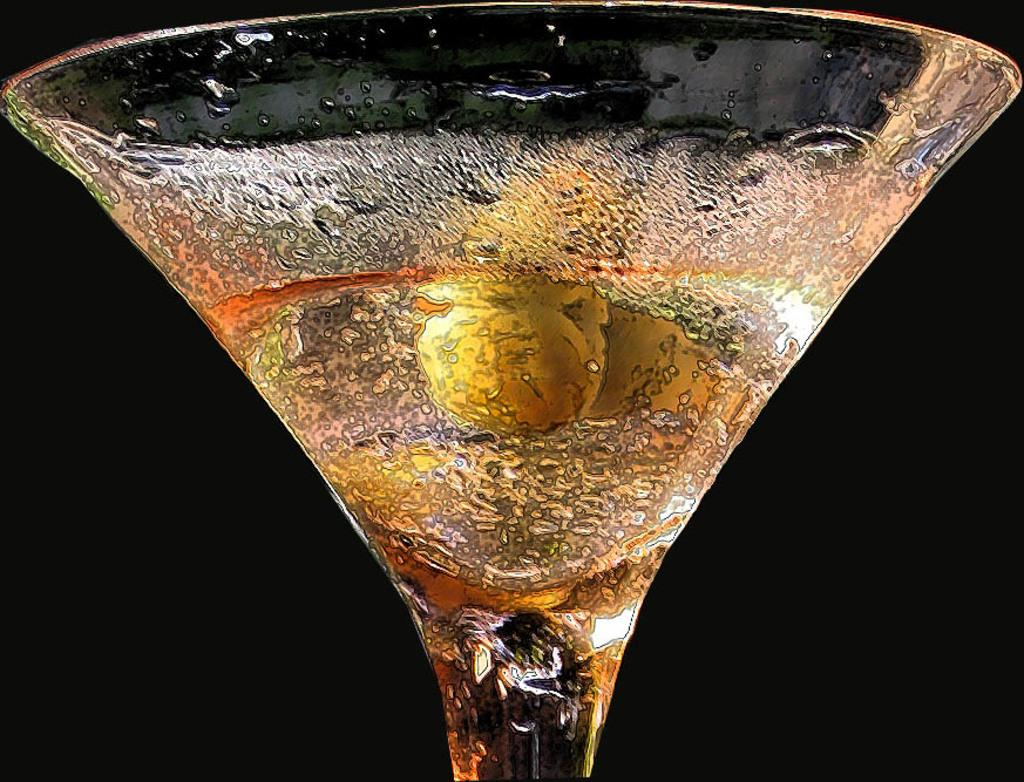What object is present in the image that can hold a liquid? There is a glass in the image. What is inside the glass? The glass contains a drink. What type of fight is taking place in the image? There is no fight present in the image; it only features a glass containing a drink. How many quarters are visible in the image? There are no quarters present in the image. 